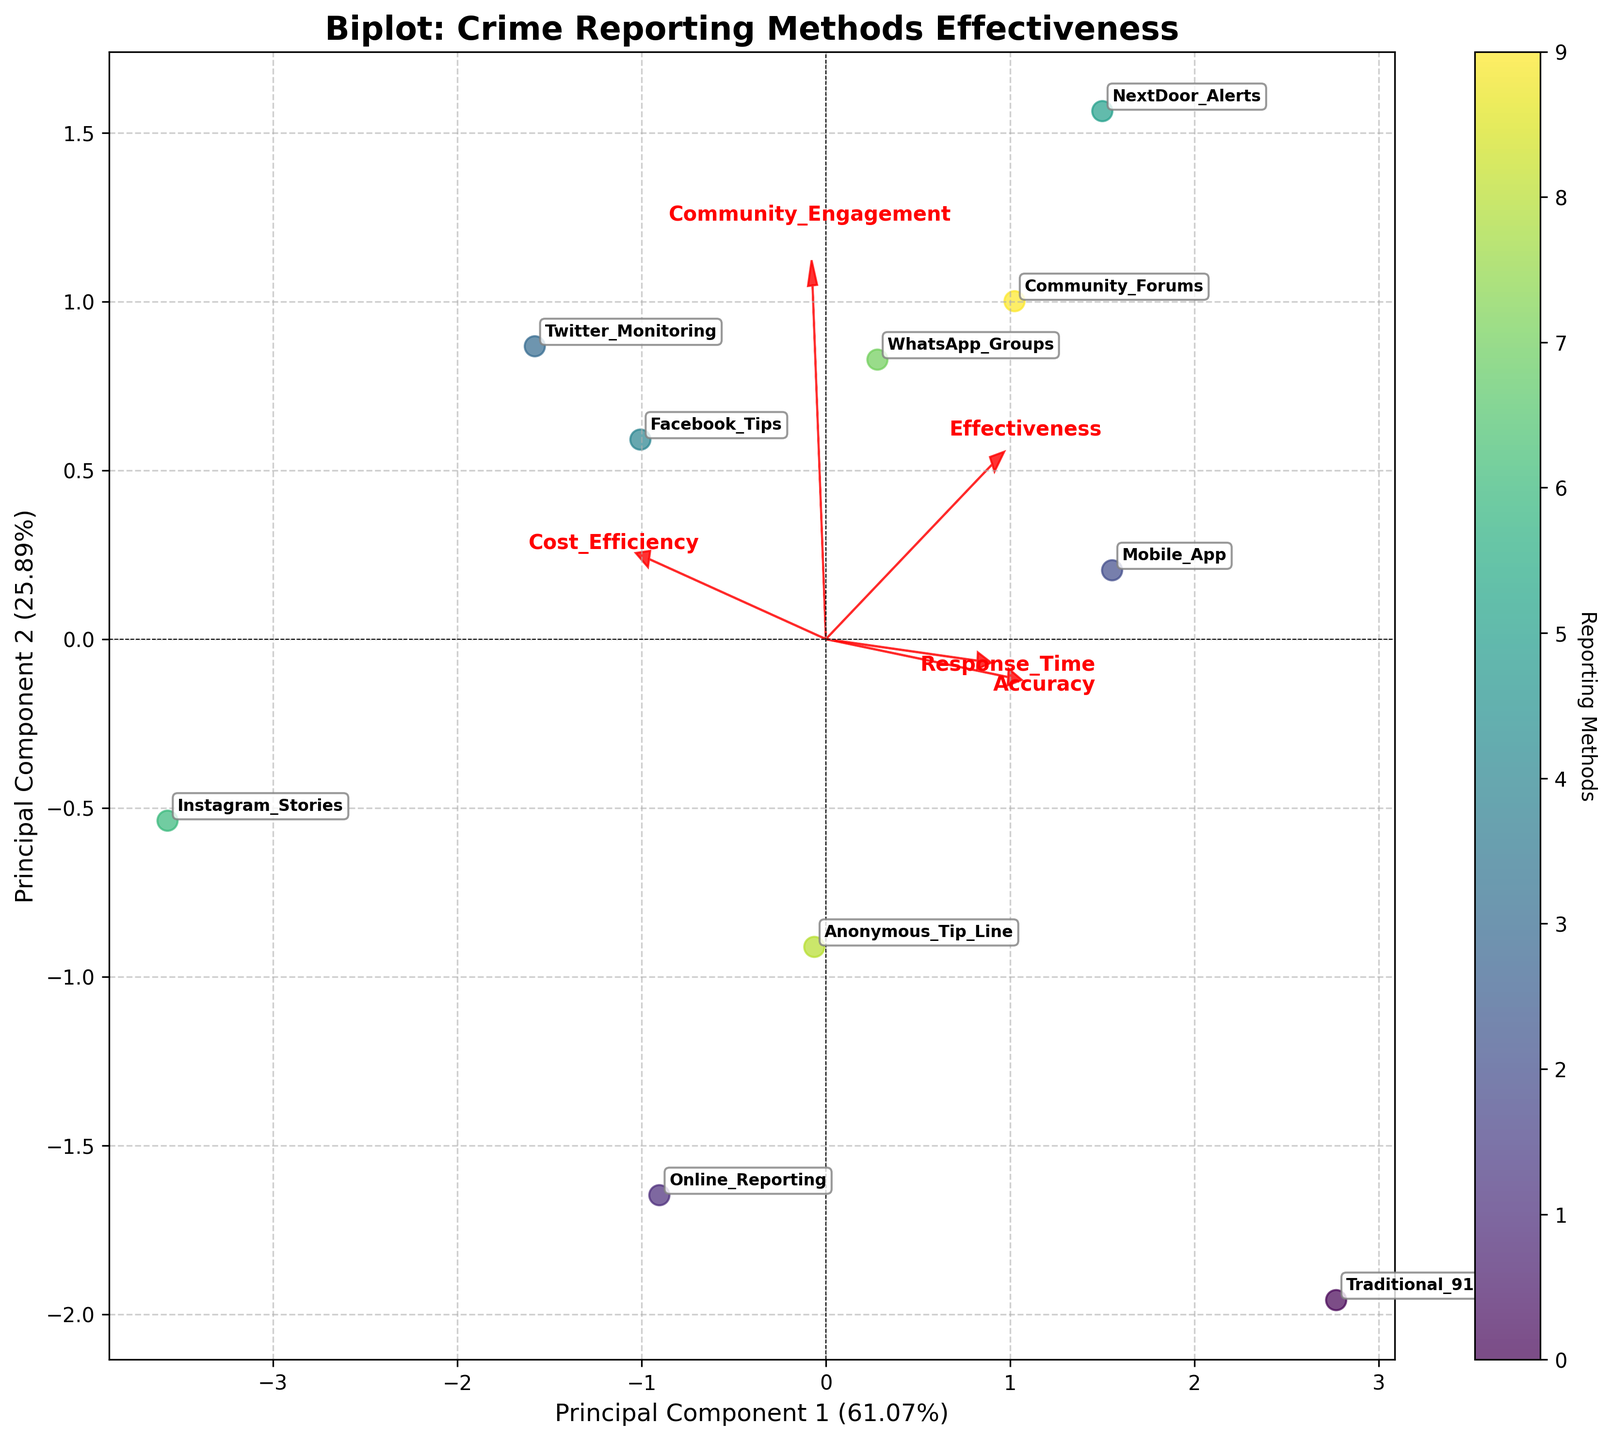What is the title of the figure? Look at the top of the figure to find the title.
Answer: Biplot: Crime Reporting Methods Effectiveness How many crime reporting methods are displayed? Count the number of labels (e.g., Traditional_911, Online_Reporting, etc.) around the scatter points on the plot.
Answer: 10 Which crime reporting method has the highest principal component 1 score? Find the data point furthest to the right (highest x-axis value) and check its label.
Answer: NextDoor_Alerts Which feature vector is most aligned with Principal Component 1? Check which arrow (feature vector) is longest along the x-axis (Principal Component 1).
Answer: Effectiveness Which method performs the best in community engagement? Look for a data point closest to the end of the 'Community_Engagement' arrow. Check its label.
Answer: NextDoor_Alerts What two methods have similar effectiveness and response time scores? Find two data points that are close to each other in terms of both Principal Component 1 and Principal Component 2 scores and check their labels.
Answer: WhatsApp_Groups and Anonymous_Tip_Line Which feature vector is least aligned with both principal components? Look for the arrow that has the smallest length.
Answer: Instagram_Stories What is the response time score for Mobile App reporting? Look at the data point labeled 'Mobile_App', then track the response time arrow to see how far along the Principal Component it lies.
Answer: 0.7 Which crime reporting methods are similarly effective but differ the most in cost efficiency? Identify two close points on the principal component 1 axis (similar effectiveness) and then compare their positions relative to the cost efficiency vector.
Answer: Traditional_911 and WhatsApp_Groups 